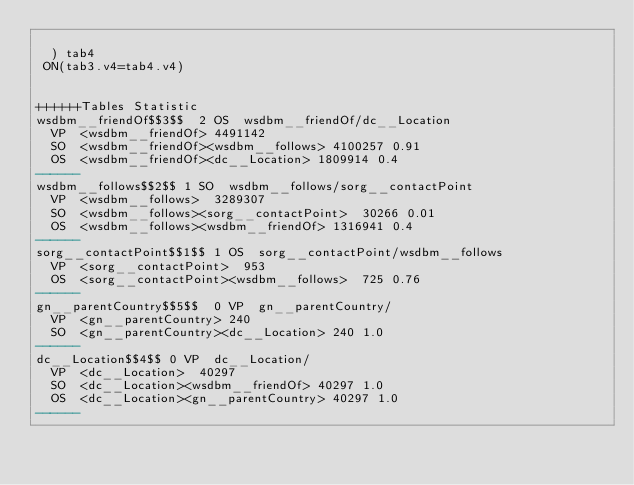Convert code to text. <code><loc_0><loc_0><loc_500><loc_500><_SQL_>	
	) tab4
 ON(tab3.v4=tab4.v4)


++++++Tables Statistic
wsdbm__friendOf$$3$$	2	OS	wsdbm__friendOf/dc__Location
	VP	<wsdbm__friendOf>	4491142
	SO	<wsdbm__friendOf><wsdbm__follows>	4100257	0.91
	OS	<wsdbm__friendOf><dc__Location>	1809914	0.4
------
wsdbm__follows$$2$$	1	SO	wsdbm__follows/sorg__contactPoint
	VP	<wsdbm__follows>	3289307
	SO	<wsdbm__follows><sorg__contactPoint>	30266	0.01
	OS	<wsdbm__follows><wsdbm__friendOf>	1316941	0.4
------
sorg__contactPoint$$1$$	1	OS	sorg__contactPoint/wsdbm__follows
	VP	<sorg__contactPoint>	953
	OS	<sorg__contactPoint><wsdbm__follows>	725	0.76
------
gn__parentCountry$$5$$	0	VP	gn__parentCountry/
	VP	<gn__parentCountry>	240
	SO	<gn__parentCountry><dc__Location>	240	1.0
------
dc__Location$$4$$	0	VP	dc__Location/
	VP	<dc__Location>	40297
	SO	<dc__Location><wsdbm__friendOf>	40297	1.0
	OS	<dc__Location><gn__parentCountry>	40297	1.0
------
</code> 